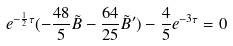<formula> <loc_0><loc_0><loc_500><loc_500>e ^ { - \frac { 1 } { 2 } \tau } ( - \frac { 4 8 } { 5 } \tilde { B } - \frac { 6 4 } { 2 5 } \tilde { B } ^ { \prime } ) - \frac { 4 } { 5 } e ^ { - 3 \tau } = 0</formula> 